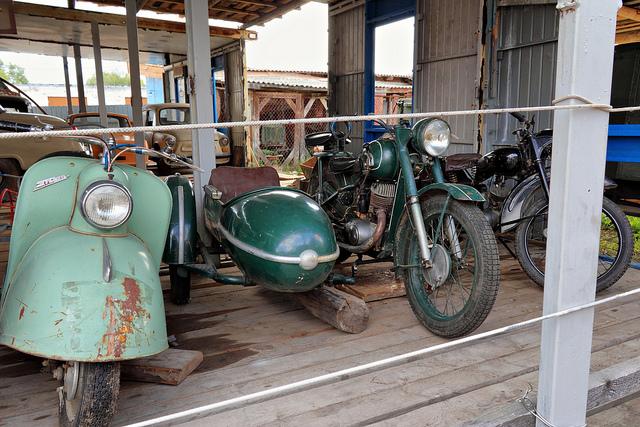Does the middle bike have a sidecar?
Write a very short answer. Yes. What would make these bikes look more appealing?
Keep it brief. Paint. Are these bikes at a bike show?
Keep it brief. No. 